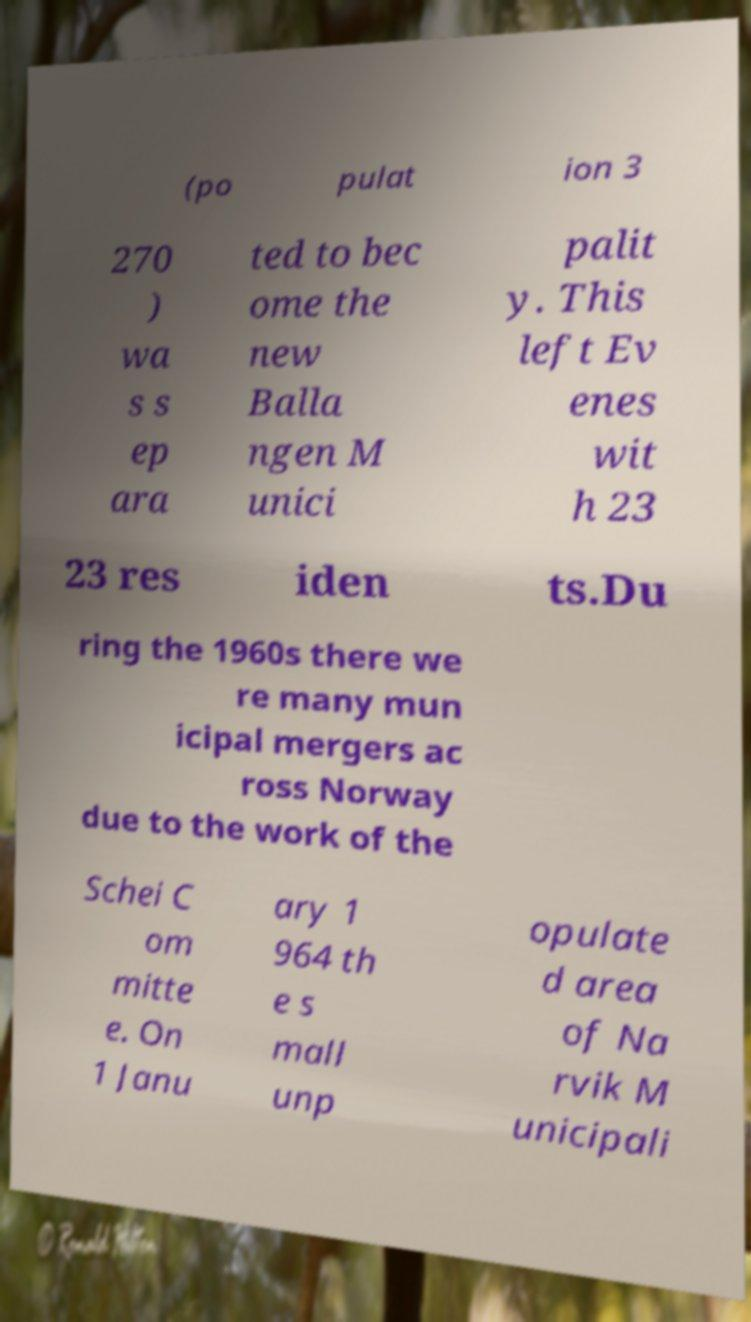Could you extract and type out the text from this image? (po pulat ion 3 270 ) wa s s ep ara ted to bec ome the new Balla ngen M unici palit y. This left Ev enes wit h 23 23 res iden ts.Du ring the 1960s there we re many mun icipal mergers ac ross Norway due to the work of the Schei C om mitte e. On 1 Janu ary 1 964 th e s mall unp opulate d area of Na rvik M unicipali 